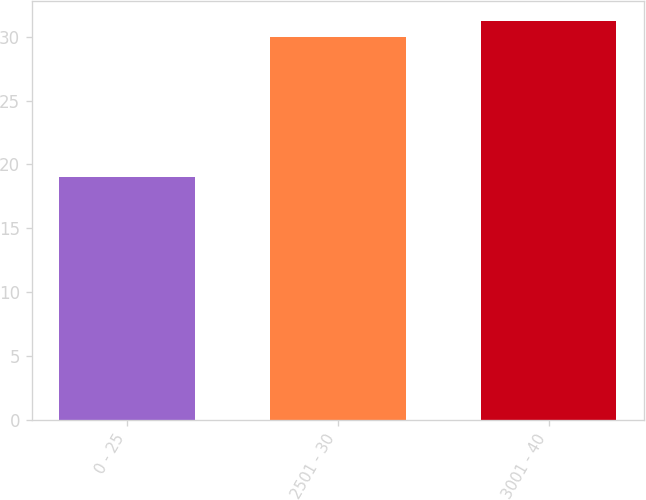Convert chart to OTSL. <chart><loc_0><loc_0><loc_500><loc_500><bar_chart><fcel>0 - 25<fcel>2501 - 30<fcel>3001 - 40<nl><fcel>19<fcel>30<fcel>31.2<nl></chart> 